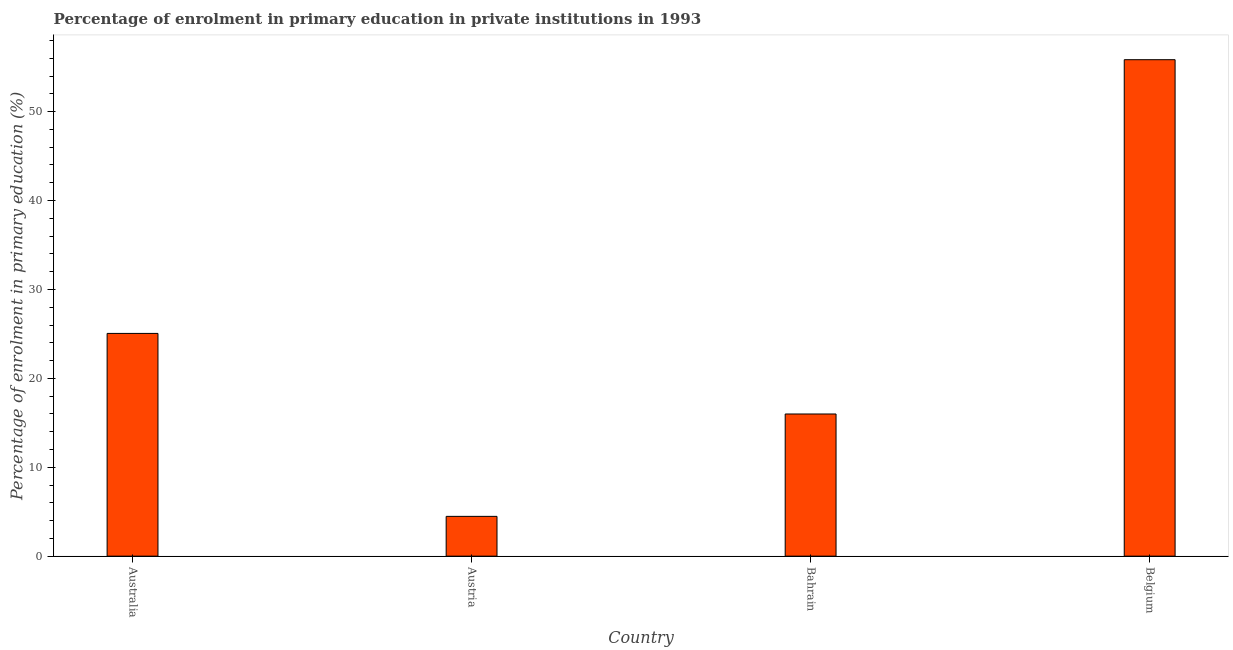Does the graph contain any zero values?
Your response must be concise. No. Does the graph contain grids?
Provide a short and direct response. No. What is the title of the graph?
Give a very brief answer. Percentage of enrolment in primary education in private institutions in 1993. What is the label or title of the Y-axis?
Give a very brief answer. Percentage of enrolment in primary education (%). What is the enrolment percentage in primary education in Austria?
Make the answer very short. 4.48. Across all countries, what is the maximum enrolment percentage in primary education?
Your answer should be compact. 55.84. Across all countries, what is the minimum enrolment percentage in primary education?
Your response must be concise. 4.48. In which country was the enrolment percentage in primary education minimum?
Provide a short and direct response. Austria. What is the sum of the enrolment percentage in primary education?
Offer a very short reply. 101.36. What is the difference between the enrolment percentage in primary education in Austria and Bahrain?
Your response must be concise. -11.52. What is the average enrolment percentage in primary education per country?
Keep it short and to the point. 25.34. What is the median enrolment percentage in primary education?
Provide a succinct answer. 20.52. In how many countries, is the enrolment percentage in primary education greater than 22 %?
Your response must be concise. 2. What is the ratio of the enrolment percentage in primary education in Australia to that in Austria?
Your answer should be very brief. 5.6. Is the difference between the enrolment percentage in primary education in Austria and Bahrain greater than the difference between any two countries?
Your answer should be very brief. No. What is the difference between the highest and the second highest enrolment percentage in primary education?
Provide a short and direct response. 30.79. What is the difference between the highest and the lowest enrolment percentage in primary education?
Provide a short and direct response. 51.36. How many bars are there?
Ensure brevity in your answer.  4. How many countries are there in the graph?
Keep it short and to the point. 4. What is the difference between two consecutive major ticks on the Y-axis?
Your answer should be compact. 10. What is the Percentage of enrolment in primary education (%) in Australia?
Offer a very short reply. 25.05. What is the Percentage of enrolment in primary education (%) of Austria?
Keep it short and to the point. 4.48. What is the Percentage of enrolment in primary education (%) in Bahrain?
Your response must be concise. 15.99. What is the Percentage of enrolment in primary education (%) of Belgium?
Ensure brevity in your answer.  55.84. What is the difference between the Percentage of enrolment in primary education (%) in Australia and Austria?
Provide a short and direct response. 20.58. What is the difference between the Percentage of enrolment in primary education (%) in Australia and Bahrain?
Give a very brief answer. 9.06. What is the difference between the Percentage of enrolment in primary education (%) in Australia and Belgium?
Provide a succinct answer. -30.78. What is the difference between the Percentage of enrolment in primary education (%) in Austria and Bahrain?
Offer a very short reply. -11.51. What is the difference between the Percentage of enrolment in primary education (%) in Austria and Belgium?
Provide a succinct answer. -51.36. What is the difference between the Percentage of enrolment in primary education (%) in Bahrain and Belgium?
Your answer should be very brief. -39.85. What is the ratio of the Percentage of enrolment in primary education (%) in Australia to that in Austria?
Ensure brevity in your answer.  5.6. What is the ratio of the Percentage of enrolment in primary education (%) in Australia to that in Bahrain?
Your response must be concise. 1.57. What is the ratio of the Percentage of enrolment in primary education (%) in Australia to that in Belgium?
Your response must be concise. 0.45. What is the ratio of the Percentage of enrolment in primary education (%) in Austria to that in Bahrain?
Keep it short and to the point. 0.28. What is the ratio of the Percentage of enrolment in primary education (%) in Bahrain to that in Belgium?
Provide a short and direct response. 0.29. 